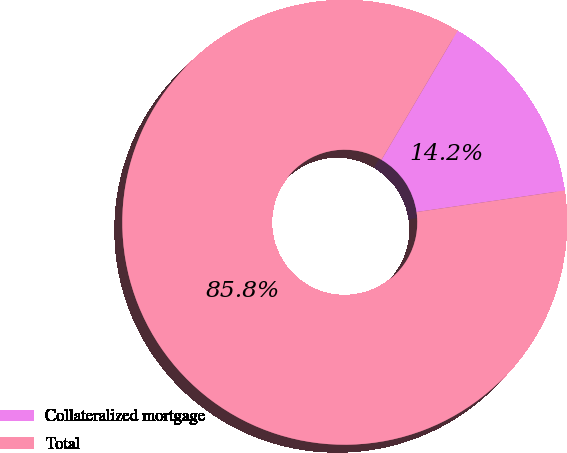<chart> <loc_0><loc_0><loc_500><loc_500><pie_chart><fcel>Collateralized mortgage<fcel>Total<nl><fcel>14.23%<fcel>85.77%<nl></chart> 